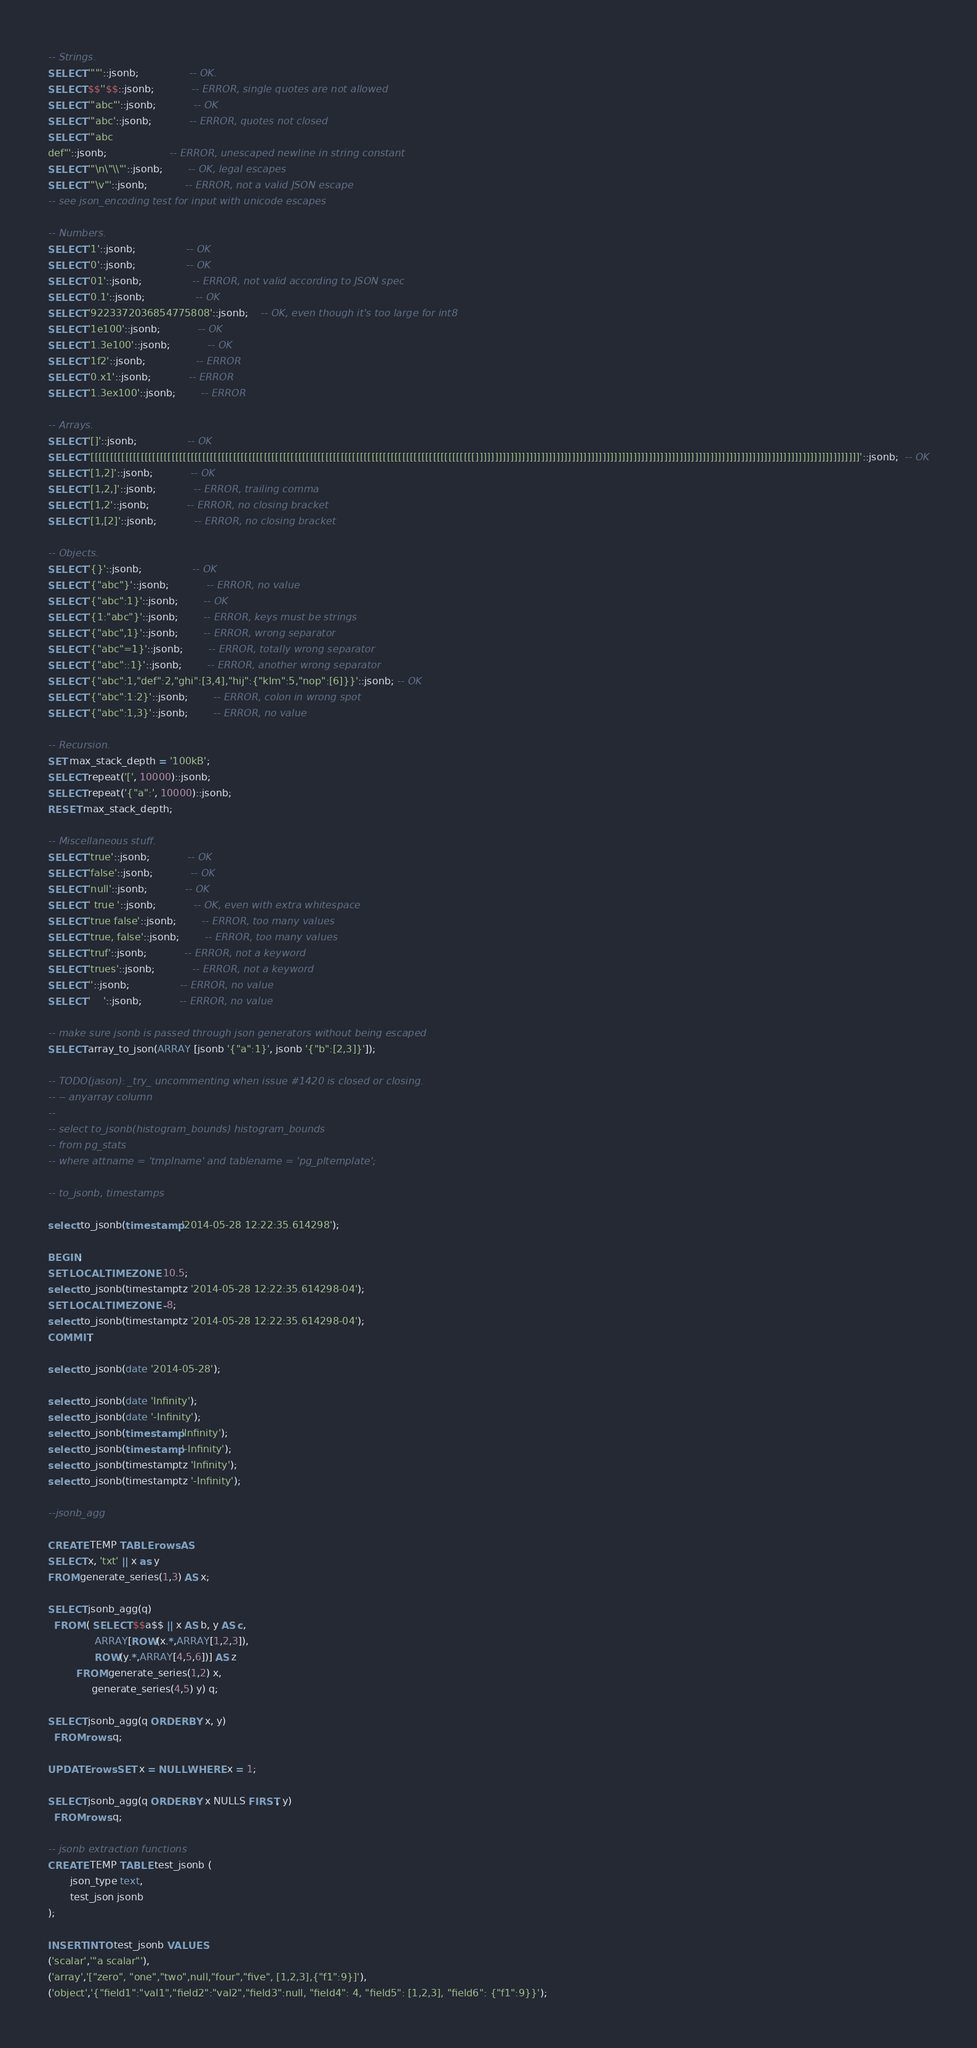Convert code to text. <code><loc_0><loc_0><loc_500><loc_500><_SQL_>-- Strings.
SELECT '""'::jsonb;				-- OK.
SELECT $$''$$::jsonb;			-- ERROR, single quotes are not allowed
SELECT '"abc"'::jsonb;			-- OK
SELECT '"abc'::jsonb;			-- ERROR, quotes not closed
SELECT '"abc
def"'::jsonb;					-- ERROR, unescaped newline in string constant
SELECT '"\n\"\\"'::jsonb;		-- OK, legal escapes
SELECT '"\v"'::jsonb;			-- ERROR, not a valid JSON escape
-- see json_encoding test for input with unicode escapes

-- Numbers.
SELECT '1'::jsonb;				-- OK
SELECT '0'::jsonb;				-- OK
SELECT '01'::jsonb;				-- ERROR, not valid according to JSON spec
SELECT '0.1'::jsonb;				-- OK
SELECT '9223372036854775808'::jsonb;	-- OK, even though it's too large for int8
SELECT '1e100'::jsonb;			-- OK
SELECT '1.3e100'::jsonb;			-- OK
SELECT '1f2'::jsonb;				-- ERROR
SELECT '0.x1'::jsonb;			-- ERROR
SELECT '1.3ex100'::jsonb;		-- ERROR

-- Arrays.
SELECT '[]'::jsonb;				-- OK
SELECT '[[[[[[[[[[[[[[[[[[[[[[[[[[[[[[[[[[[[[[[[[[[[[[[[[[[[[[[[[[[[[[[[[[[[[[[[[[[[[[[[[[[[[[[[[[[[[[[[[[[[]]]]]]]]]]]]]]]]]]]]]]]]]]]]]]]]]]]]]]]]]]]]]]]]]]]]]]]]]]]]]]]]]]]]]]]]]]]]]]]]]]]]]]]]]]]]]]]]]]]]'::jsonb;  -- OK
SELECT '[1,2]'::jsonb;			-- OK
SELECT '[1,2,]'::jsonb;			-- ERROR, trailing comma
SELECT '[1,2'::jsonb;			-- ERROR, no closing bracket
SELECT '[1,[2]'::jsonb;			-- ERROR, no closing bracket

-- Objects.
SELECT '{}'::jsonb;				-- OK
SELECT '{"abc"}'::jsonb;			-- ERROR, no value
SELECT '{"abc":1}'::jsonb;		-- OK
SELECT '{1:"abc"}'::jsonb;		-- ERROR, keys must be strings
SELECT '{"abc",1}'::jsonb;		-- ERROR, wrong separator
SELECT '{"abc"=1}'::jsonb;		-- ERROR, totally wrong separator
SELECT '{"abc"::1}'::jsonb;		-- ERROR, another wrong separator
SELECT '{"abc":1,"def":2,"ghi":[3,4],"hij":{"klm":5,"nop":[6]}}'::jsonb; -- OK
SELECT '{"abc":1:2}'::jsonb;		-- ERROR, colon in wrong spot
SELECT '{"abc":1,3}'::jsonb;		-- ERROR, no value

-- Recursion.
SET max_stack_depth = '100kB';
SELECT repeat('[', 10000)::jsonb;
SELECT repeat('{"a":', 10000)::jsonb;
RESET max_stack_depth;

-- Miscellaneous stuff.
SELECT 'true'::jsonb;			-- OK
SELECT 'false'::jsonb;			-- OK
SELECT 'null'::jsonb;			-- OK
SELECT ' true '::jsonb;			-- OK, even with extra whitespace
SELECT 'true false'::jsonb;		-- ERROR, too many values
SELECT 'true, false'::jsonb;		-- ERROR, too many values
SELECT 'truf'::jsonb;			-- ERROR, not a keyword
SELECT 'trues'::jsonb;			-- ERROR, not a keyword
SELECT ''::jsonb;				-- ERROR, no value
SELECT '    '::jsonb;			-- ERROR, no value

-- make sure jsonb is passed through json generators without being escaped
SELECT array_to_json(ARRAY [jsonb '{"a":1}', jsonb '{"b":[2,3]}']);

-- TODO(jason): _try_ uncommenting when issue #1420 is closed or closing.
-- -- anyarray column
--
-- select to_jsonb(histogram_bounds) histogram_bounds
-- from pg_stats
-- where attname = 'tmplname' and tablename = 'pg_pltemplate';

-- to_jsonb, timestamps

select to_jsonb(timestamp '2014-05-28 12:22:35.614298');

BEGIN;
SET LOCAL TIME ZONE 10.5;
select to_jsonb(timestamptz '2014-05-28 12:22:35.614298-04');
SET LOCAL TIME ZONE -8;
select to_jsonb(timestamptz '2014-05-28 12:22:35.614298-04');
COMMIT;

select to_jsonb(date '2014-05-28');

select to_jsonb(date 'Infinity');
select to_jsonb(date '-Infinity');
select to_jsonb(timestamp 'Infinity');
select to_jsonb(timestamp '-Infinity');
select to_jsonb(timestamptz 'Infinity');
select to_jsonb(timestamptz '-Infinity');

--jsonb_agg

CREATE TEMP TABLE rows AS
SELECT x, 'txt' || x as y
FROM generate_series(1,3) AS x;

SELECT jsonb_agg(q)
  FROM ( SELECT $$a$$ || x AS b, y AS c,
               ARRAY[ROW(x.*,ARRAY[1,2,3]),
               ROW(y.*,ARRAY[4,5,6])] AS z
         FROM generate_series(1,2) x,
              generate_series(4,5) y) q;

SELECT jsonb_agg(q ORDER BY x, y)
  FROM rows q;

UPDATE rows SET x = NULL WHERE x = 1;

SELECT jsonb_agg(q ORDER BY x NULLS FIRST, y)
  FROM rows q;

-- jsonb extraction functions
CREATE TEMP TABLE test_jsonb (
       json_type text,
       test_json jsonb
);

INSERT INTO test_jsonb VALUES
('scalar','"a scalar"'),
('array','["zero", "one","two",null,"four","five", [1,2,3],{"f1":9}]'),
('object','{"field1":"val1","field2":"val2","field3":null, "field4": 4, "field5": [1,2,3], "field6": {"f1":9}}');
</code> 